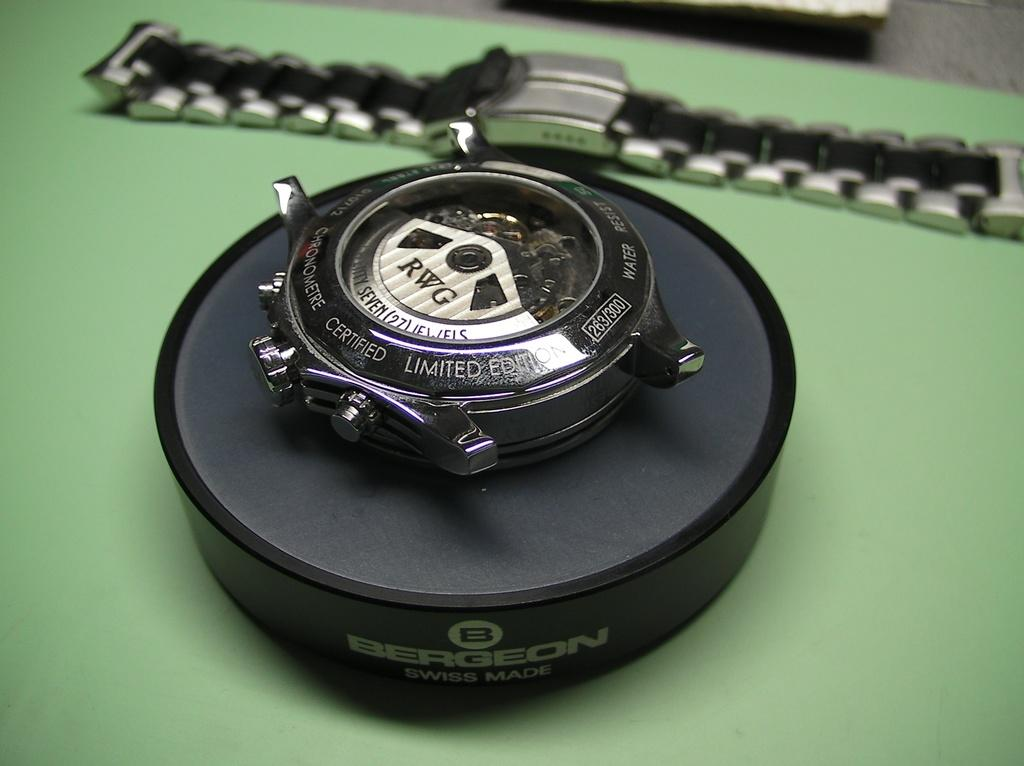<image>
Relay a brief, clear account of the picture shown. A watch made by RWG sits on a stand on a green counter. 